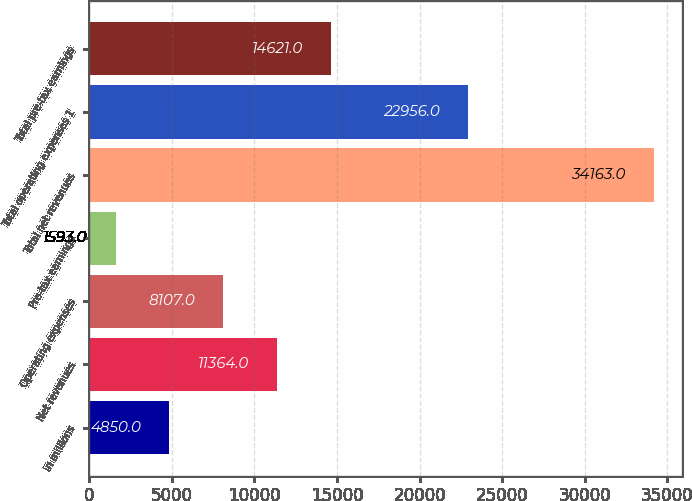Convert chart to OTSL. <chart><loc_0><loc_0><loc_500><loc_500><bar_chart><fcel>in millions<fcel>Net revenues<fcel>Operating expenses<fcel>Pre-tax earnings<fcel>Total net revenues<fcel>Total operating expenses 1<fcel>Total pre-tax earnings<nl><fcel>4850<fcel>11364<fcel>8107<fcel>1593<fcel>34163<fcel>22956<fcel>14621<nl></chart> 